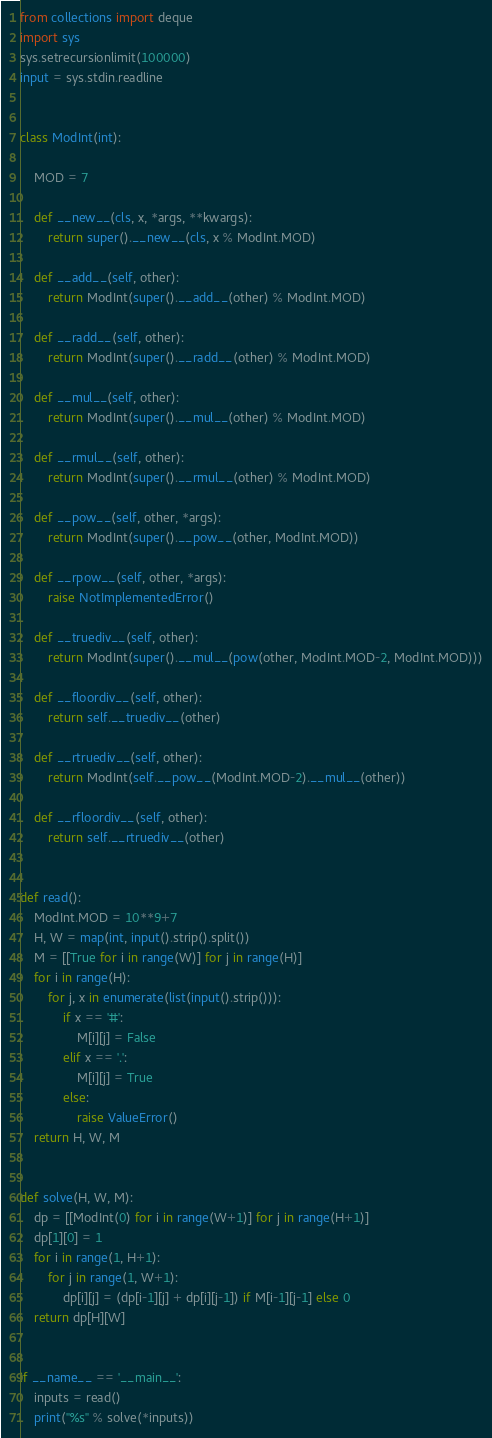Convert code to text. <code><loc_0><loc_0><loc_500><loc_500><_Python_>from collections import deque
import sys
sys.setrecursionlimit(100000)
input = sys.stdin.readline


class ModInt(int):
    
    MOD = 7

    def __new__(cls, x, *args, **kwargs):
        return super().__new__(cls, x % ModInt.MOD)

    def __add__(self, other):
        return ModInt(super().__add__(other) % ModInt.MOD)
    
    def __radd__(self, other):
        return ModInt(super().__radd__(other) % ModInt.MOD)
    
    def __mul__(self, other):
        return ModInt(super().__mul__(other) % ModInt.MOD)
    
    def __rmul__(self, other):
        return ModInt(super().__rmul__(other) % ModInt.MOD)
    
    def __pow__(self, other, *args):
        return ModInt(super().__pow__(other, ModInt.MOD))

    def __rpow__(self, other, *args):
        raise NotImplementedError()
    
    def __truediv__(self, other):
        return ModInt(super().__mul__(pow(other, ModInt.MOD-2, ModInt.MOD)))
    
    def __floordiv__(self, other):
        return self.__truediv__(other)
    
    def __rtruediv__(self, other):
        return ModInt(self.__pow__(ModInt.MOD-2).__mul__(other))
    
    def __rfloordiv__(self, other):
        return self.__rtruediv__(other)


def read():
    ModInt.MOD = 10**9+7
    H, W = map(int, input().strip().split())
    M = [[True for i in range(W)] for j in range(H)]
    for i in range(H):
        for j, x in enumerate(list(input().strip())):
            if x == '#':
                M[i][j] = False
            elif x == '.':
                M[i][j] = True
            else:
                raise ValueError()
    return H, W, M


def solve(H, W, M):
    dp = [[ModInt(0) for i in range(W+1)] for j in range(H+1)]
    dp[1][0] = 1
    for i in range(1, H+1):
        for j in range(1, W+1):
            dp[i][j] = (dp[i-1][j] + dp[i][j-1]) if M[i-1][j-1] else 0
    return dp[H][W]


if __name__ == '__main__':
    inputs = read()
    print("%s" % solve(*inputs))
</code> 